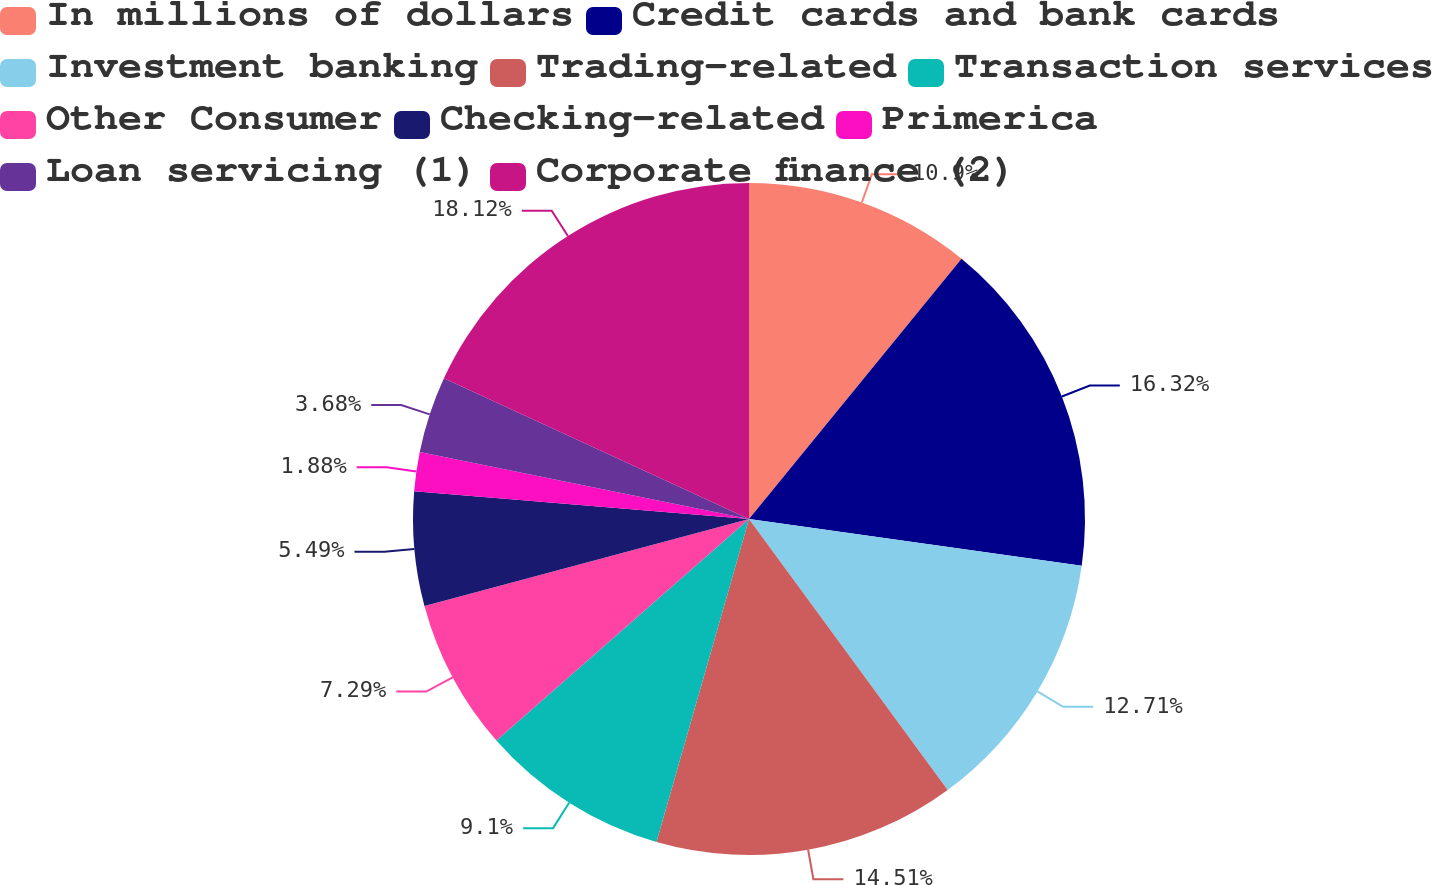Convert chart. <chart><loc_0><loc_0><loc_500><loc_500><pie_chart><fcel>In millions of dollars<fcel>Credit cards and bank cards<fcel>Investment banking<fcel>Trading-related<fcel>Transaction services<fcel>Other Consumer<fcel>Checking-related<fcel>Primerica<fcel>Loan servicing (1)<fcel>Corporate finance (2)<nl><fcel>10.9%<fcel>16.32%<fcel>12.71%<fcel>14.51%<fcel>9.1%<fcel>7.29%<fcel>5.49%<fcel>1.88%<fcel>3.68%<fcel>18.12%<nl></chart> 